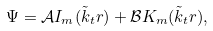<formula> <loc_0><loc_0><loc_500><loc_500>\Psi = \mathcal { A } I _ { m } ( \tilde { k } _ { t } r ) + \mathcal { B } K _ { m } ( \tilde { k } _ { t } r ) ,</formula> 